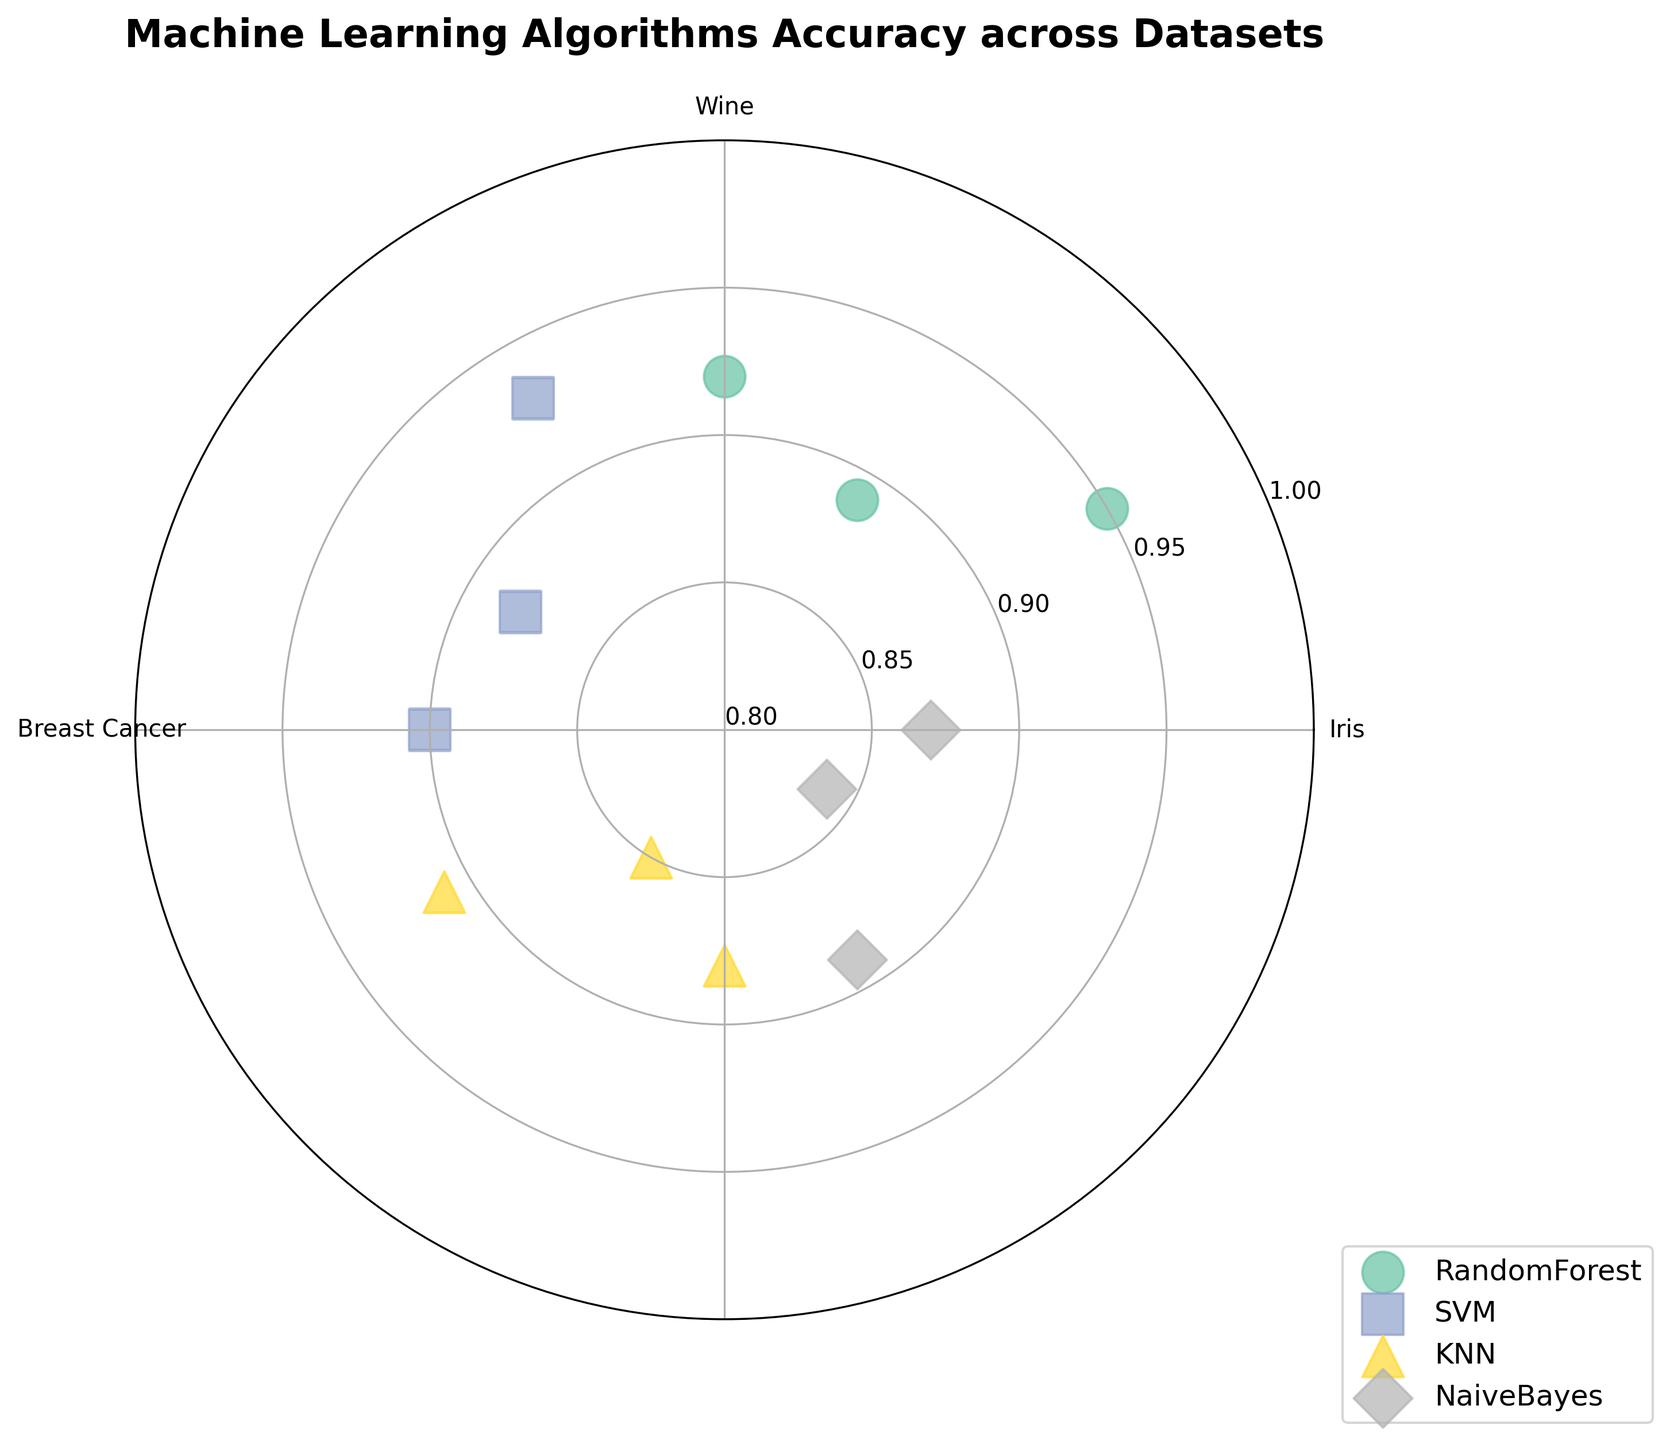What is the title of the chart? The title of the chart is displayed prominently at the top. It reads "Machine Learning Algorithms Accuracy across Datasets."
Answer: Machine Learning Algorithms Accuracy across Datasets Which machine learning algorithm has the highest accuracy on the Iris dataset? To determine the algorithm with the highest accuracy on the Iris dataset, look at the scatter points located around the "0 degrees" (Iris) angle. The height of the points represents accuracy. The Random Forest algorithm has a point at roughly 0.95, which is the highest among all.
Answer: Random Forest What is the accuracy range covered in the chart? The radial axis represents accuracy. The range can be observed from the minimum to the maximum value marked, which are 0.8 and 1.0, respectively.
Answer: 0.8 to 1.0 Which algorithm shows the lowest accuracy on the Wine dataset, and what is this accuracy? Look at the scatter points around "60 degrees" (Wine). The points' vertical positions indicate accuracy. The Naive Bayes algorithm has the lowest point here, with an accuracy of 0.84.
Answer: Naive Bayes with 0.84 Compare the accuracy of the SVM and KNN algorithms on the Breast Cancer dataset. Which one performs better? Locate the scatter points around "90 degrees" for Breast Cancer. Check the heights for SVM and KNN. SVM has a point at 0.90, whereas KNN has a point at 0.88. SVM performs better.
Answer: SVM What is the average accuracy of the Random Forest algorithm across all datasets? Calculate the average of Random Forest's accuracies listed: (0.95 for Iris, 0.89 for Wine, and 0.92 for Breast Cancer). The sum is 0.95 + 0.89 + 0.92 = 2.76. Divide this sum by 3 to get the average: 2.76 / 3 = 0.92.
Answer: 0.92 Which machine learning algorithm has the most consistent performance across the datasets? Consistency can be inferred from the cluster of points around the same height. Random Forest and SVM show clustered points across their data sets, but Random Forest has less variation (0.95, 0.89, 0.92). Random Forest is the most consistent.
Answer: Random Forest How does the accuracy of the Naive Bayes algorithm on the Breast Cancer dataset compare to the KNN algorithm on the same dataset? Focus on the points around "90 degrees" and "270 degrees." Naive Bayes for Breast Cancer is at 0.87, while KNN is at 0.88. KNN is slightly better.
Answer: KNN What is the angle associated with the SVM algorithm on the Wine dataset? Observe the SVM color and marker type, then look at the angle they've scattered for Wine. The angle is shown as 150 degrees.
Answer: 150 degrees 